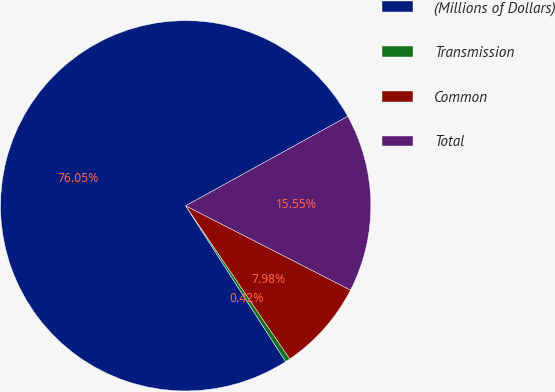Convert chart. <chart><loc_0><loc_0><loc_500><loc_500><pie_chart><fcel>(Millions of Dollars)<fcel>Transmission<fcel>Common<fcel>Total<nl><fcel>76.06%<fcel>0.42%<fcel>7.98%<fcel>15.55%<nl></chart> 